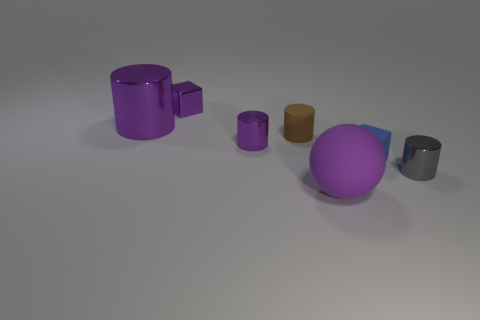Subtract all purple cylinders. How many were subtracted if there are1purple cylinders left? 1 Subtract all shiny cylinders. How many cylinders are left? 1 Subtract 3 cylinders. How many cylinders are left? 1 Add 1 small purple matte spheres. How many objects exist? 8 Subtract all purple cylinders. How many cylinders are left? 2 Subtract all blocks. How many objects are left? 5 Subtract all red blocks. How many purple cylinders are left? 2 Subtract all blue metallic spheres. Subtract all purple objects. How many objects are left? 3 Add 6 large purple cylinders. How many large purple cylinders are left? 7 Add 1 gray things. How many gray things exist? 2 